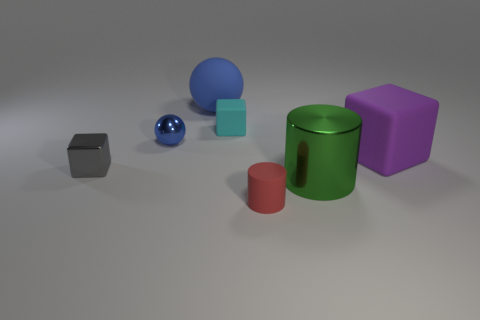Add 3 matte spheres. How many objects exist? 10 Subtract all blocks. How many objects are left? 4 Add 5 yellow rubber blocks. How many yellow rubber blocks exist? 5 Subtract 0 brown balls. How many objects are left? 7 Subtract all tiny red matte spheres. Subtract all tiny red rubber objects. How many objects are left? 6 Add 4 large blocks. How many large blocks are left? 5 